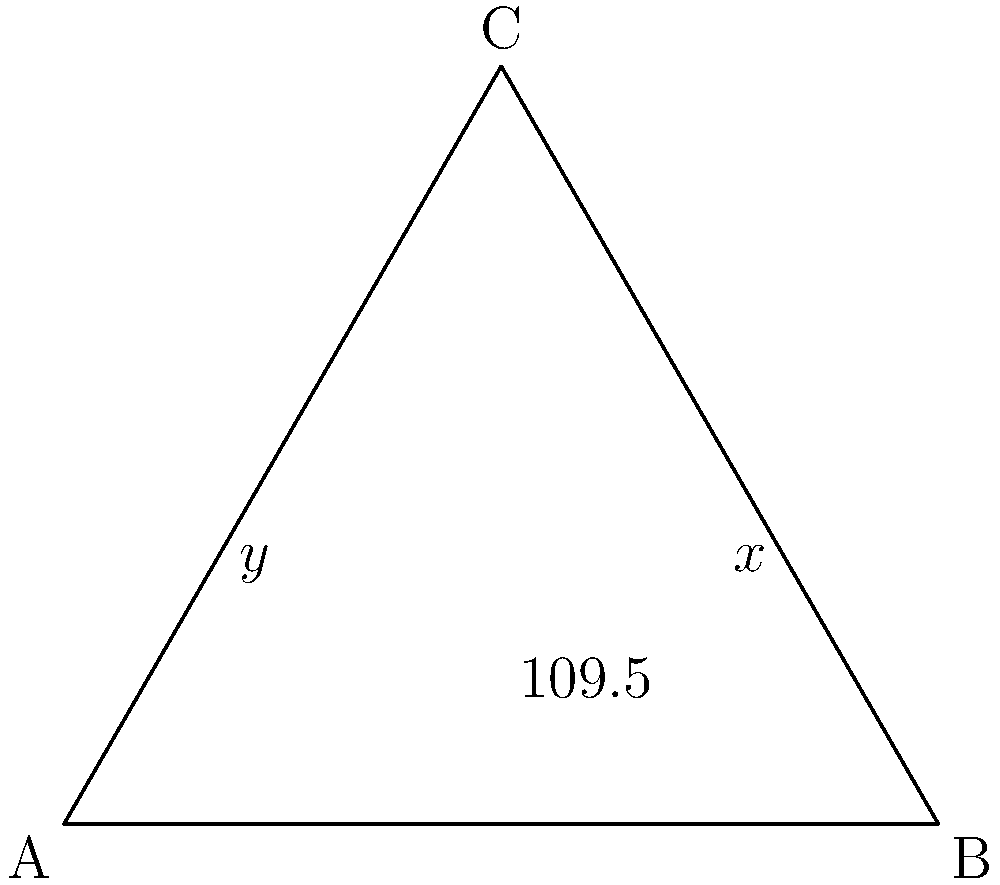In a planar molecule of a newly synthesized drug, three atoms form a triangle ABC as shown. The angle at B is known to be 109.5°, which is characteristic of sp³ hybridization. If the molecule is planar, what is the sum of angles x and y? To solve this problem, we'll follow these steps:

1) In any triangle, the sum of all interior angles is always 180°.

2) We're given that angle B is 109.5°.

3) Let's call the angle at C as z°. So, we can write:
   $$x° + y° + z° + 109.5° = 180°$$

4) In a planar molecule, all atoms lie in the same plane. This means that the angles around any atom in the plane should sum to 360°.

5) At point A, we see three angles: x°, y°, and the angle between them (which is the exterior angle of the triangle at A).

6) The exterior angle of a triangle is supplementary to the interior angle. So, the exterior angle at A is $(180° - z°)$.

7) Therefore, at point A:
   $$x° + y° + (180° - z°) = 360°$$

8) Simplifying:
   $$x° + y° - z° = 180°$$

9) This is the same equation we derived in step 3, just rearranged.

10) Therefore, $x° + y° = 180° - 109.5° = 70.5°$
Answer: 70.5° 